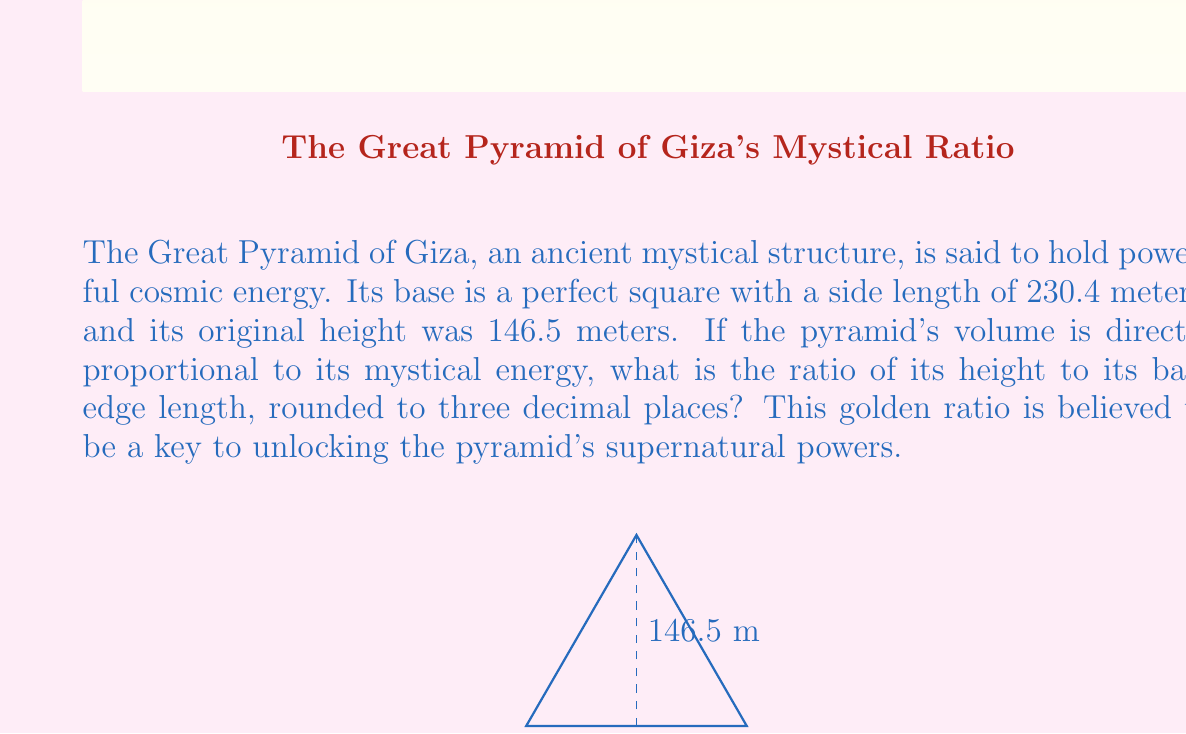What is the answer to this math problem? To find the ratio of the pyramid's height to its base edge length, we need to divide the height by the base edge length. This calculation involves the following steps:

1. Height of the pyramid: $h = 146.5$ meters
2. Base edge length: $b = 230.4$ meters

The ratio $r$ is given by:

$$r = \frac{h}{b} = \frac{146.5}{230.4}$$

Using a calculator or computer to perform the division:

$$r \approx 0.6358506944444444$$

Rounding to three decimal places:

$$r \approx 0.636$$

This ratio, often referred to as the "sacred ratio" in mystical studies, is believed to be imbued with supernatural significance. It's thought to channel cosmic energies and align the pyramid with celestial forces.
Answer: 0.636 